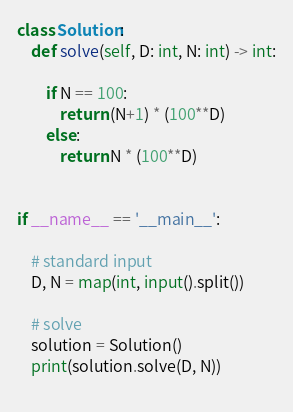<code> <loc_0><loc_0><loc_500><loc_500><_Python_>class Solution:
    def solve(self, D: int, N: int) -> int:

        if N == 100:
            return (N+1) * (100**D)
        else:
            return N * (100**D)


if __name__ == '__main__':

    # standard input
    D, N = map(int, input().split())

    # solve
    solution = Solution()
    print(solution.solve(D, N))
    </code> 